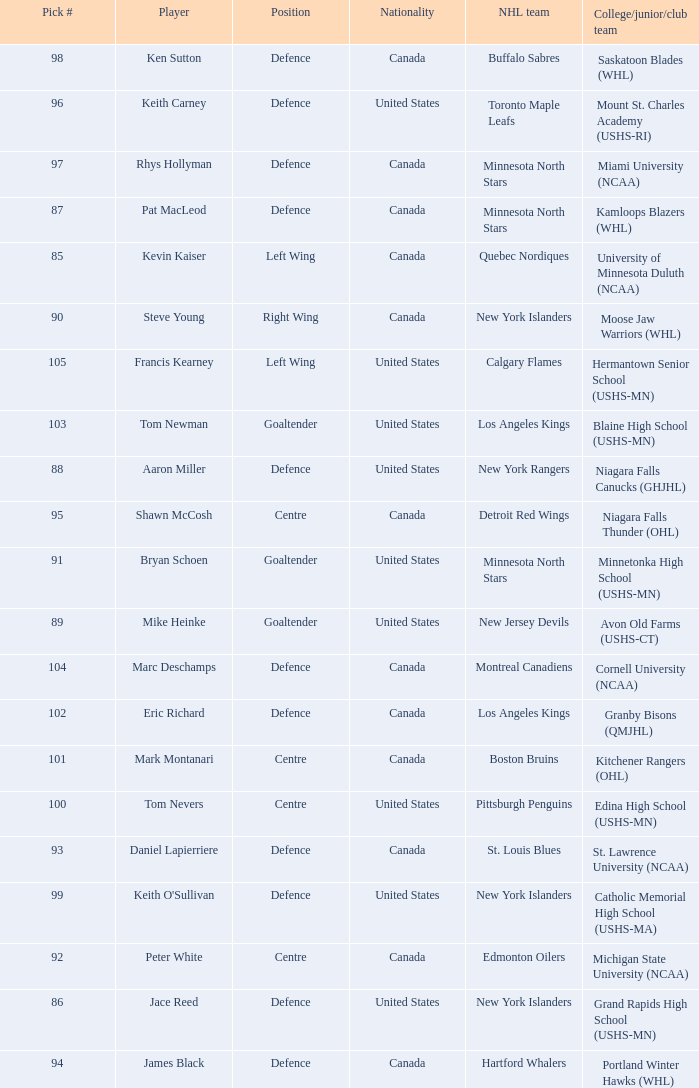What pick number was marc deschamps? 104.0. Give me the full table as a dictionary. {'header': ['Pick #', 'Player', 'Position', 'Nationality', 'NHL team', 'College/junior/club team'], 'rows': [['98', 'Ken Sutton', 'Defence', 'Canada', 'Buffalo Sabres', 'Saskatoon Blades (WHL)'], ['96', 'Keith Carney', 'Defence', 'United States', 'Toronto Maple Leafs', 'Mount St. Charles Academy (USHS-RI)'], ['97', 'Rhys Hollyman', 'Defence', 'Canada', 'Minnesota North Stars', 'Miami University (NCAA)'], ['87', 'Pat MacLeod', 'Defence', 'Canada', 'Minnesota North Stars', 'Kamloops Blazers (WHL)'], ['85', 'Kevin Kaiser', 'Left Wing', 'Canada', 'Quebec Nordiques', 'University of Minnesota Duluth (NCAA)'], ['90', 'Steve Young', 'Right Wing', 'Canada', 'New York Islanders', 'Moose Jaw Warriors (WHL)'], ['105', 'Francis Kearney', 'Left Wing', 'United States', 'Calgary Flames', 'Hermantown Senior School (USHS-MN)'], ['103', 'Tom Newman', 'Goaltender', 'United States', 'Los Angeles Kings', 'Blaine High School (USHS-MN)'], ['88', 'Aaron Miller', 'Defence', 'United States', 'New York Rangers', 'Niagara Falls Canucks (GHJHL)'], ['95', 'Shawn McCosh', 'Centre', 'Canada', 'Detroit Red Wings', 'Niagara Falls Thunder (OHL)'], ['91', 'Bryan Schoen', 'Goaltender', 'United States', 'Minnesota North Stars', 'Minnetonka High School (USHS-MN)'], ['89', 'Mike Heinke', 'Goaltender', 'United States', 'New Jersey Devils', 'Avon Old Farms (USHS-CT)'], ['104', 'Marc Deschamps', 'Defence', 'Canada', 'Montreal Canadiens', 'Cornell University (NCAA)'], ['102', 'Eric Richard', 'Defence', 'Canada', 'Los Angeles Kings', 'Granby Bisons (QMJHL)'], ['101', 'Mark Montanari', 'Centre', 'Canada', 'Boston Bruins', 'Kitchener Rangers (OHL)'], ['100', 'Tom Nevers', 'Centre', 'United States', 'Pittsburgh Penguins', 'Edina High School (USHS-MN)'], ['93', 'Daniel Lapierriere', 'Defence', 'Canada', 'St. Louis Blues', 'St. Lawrence University (NCAA)'], ['99', "Keith O'Sullivan", 'Defence', 'United States', 'New York Islanders', 'Catholic Memorial High School (USHS-MA)'], ['92', 'Peter White', 'Centre', 'Canada', 'Edmonton Oilers', 'Michigan State University (NCAA)'], ['86', 'Jace Reed', 'Defence', 'United States', 'New York Islanders', 'Grand Rapids High School (USHS-MN)'], ['94', 'James Black', 'Defence', 'Canada', 'Hartford Whalers', 'Portland Winter Hawks (WHL)']]} 